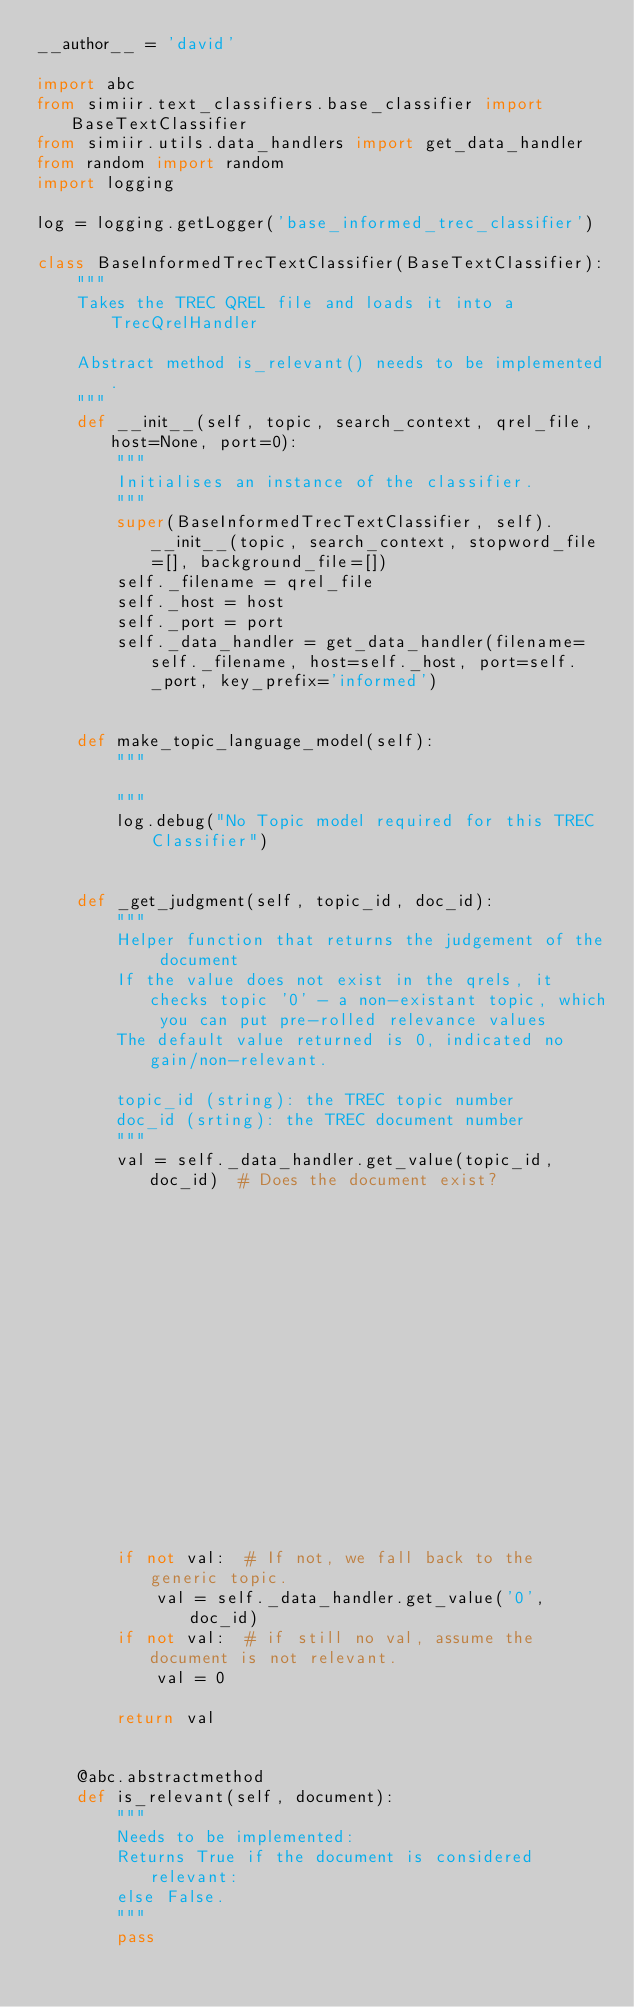<code> <loc_0><loc_0><loc_500><loc_500><_Python_>__author__ = 'david'

import abc
from simiir.text_classifiers.base_classifier import BaseTextClassifier
from simiir.utils.data_handlers import get_data_handler
from random import random
import logging

log = logging.getLogger('base_informed_trec_classifier')

class BaseInformedTrecTextClassifier(BaseTextClassifier):
    """
    Takes the TREC QREL file and loads it into a TrecQrelHandler

    Abstract method is_relevant() needs to be implemented.
    """
    def __init__(self, topic, search_context, qrel_file, host=None, port=0):
        """
        Initialises an instance of the classifier.
        """
        super(BaseInformedTrecTextClassifier, self).__init__(topic, search_context, stopword_file=[], background_file=[])
        self._filename = qrel_file
        self._host = host
        self._port = port
        self._data_handler = get_data_handler(filename=self._filename, host=self._host, port=self._port, key_prefix='informed')
    
    
    def make_topic_language_model(self):
        """
        
        """
        log.debug("No Topic model required for this TREC Classifier")
    
    
    def _get_judgment(self, topic_id, doc_id):
        """
        Helper function that returns the judgement of the document
        If the value does not exist in the qrels, it checks topic '0' - a non-existant topic, which you can put pre-rolled relevance values
        The default value returned is 0, indicated no gain/non-relevant.

        topic_id (string): the TREC topic number
        doc_id (srting): the TREC document number
        """
        val = self._data_handler.get_value(topic_id, doc_id)  # Does the document exist?
                                                              # Pulls the answer from the data handler.

        if not val:  # If not, we fall back to the generic topic.
            val = self._data_handler.get_value('0', doc_id)
        if not val:  # if still no val, assume the document is not relevant.
            val = 0

        return val


    @abc.abstractmethod
    def is_relevant(self, document):
        """
        Needs to be implemented:
        Returns True if the document is considered relevant:
        else False.
        """
        pass

</code> 